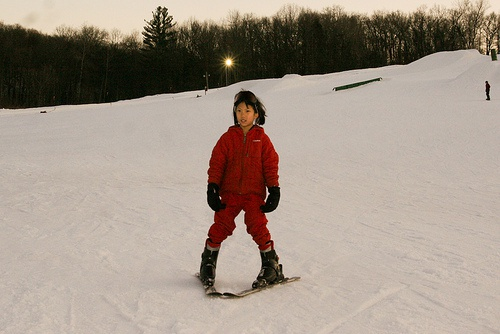Describe the objects in this image and their specific colors. I can see people in lightgray, maroon, black, and brown tones, skis in lightgray, black, and gray tones, and people in lightgray, black, darkgray, gray, and darkgreen tones in this image. 